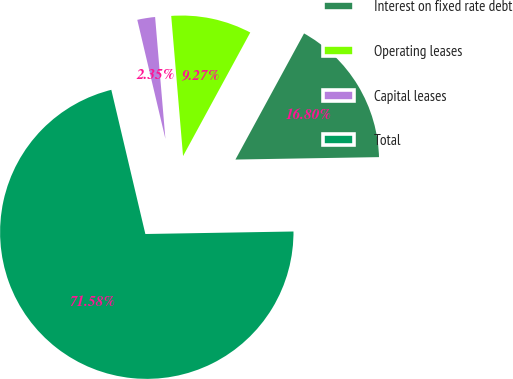Convert chart. <chart><loc_0><loc_0><loc_500><loc_500><pie_chart><fcel>Interest on fixed rate debt<fcel>Operating leases<fcel>Capital leases<fcel>Total<nl><fcel>16.8%<fcel>9.27%<fcel>2.35%<fcel>71.57%<nl></chart> 